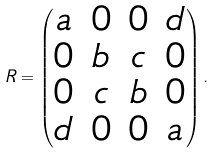Convert formula to latex. <formula><loc_0><loc_0><loc_500><loc_500>R = \begin{pmatrix} a & 0 & 0 & d \\ 0 & b & c & 0 \\ 0 & c & b & 0 \\ d & 0 & 0 & a \end{pmatrix} .</formula> 